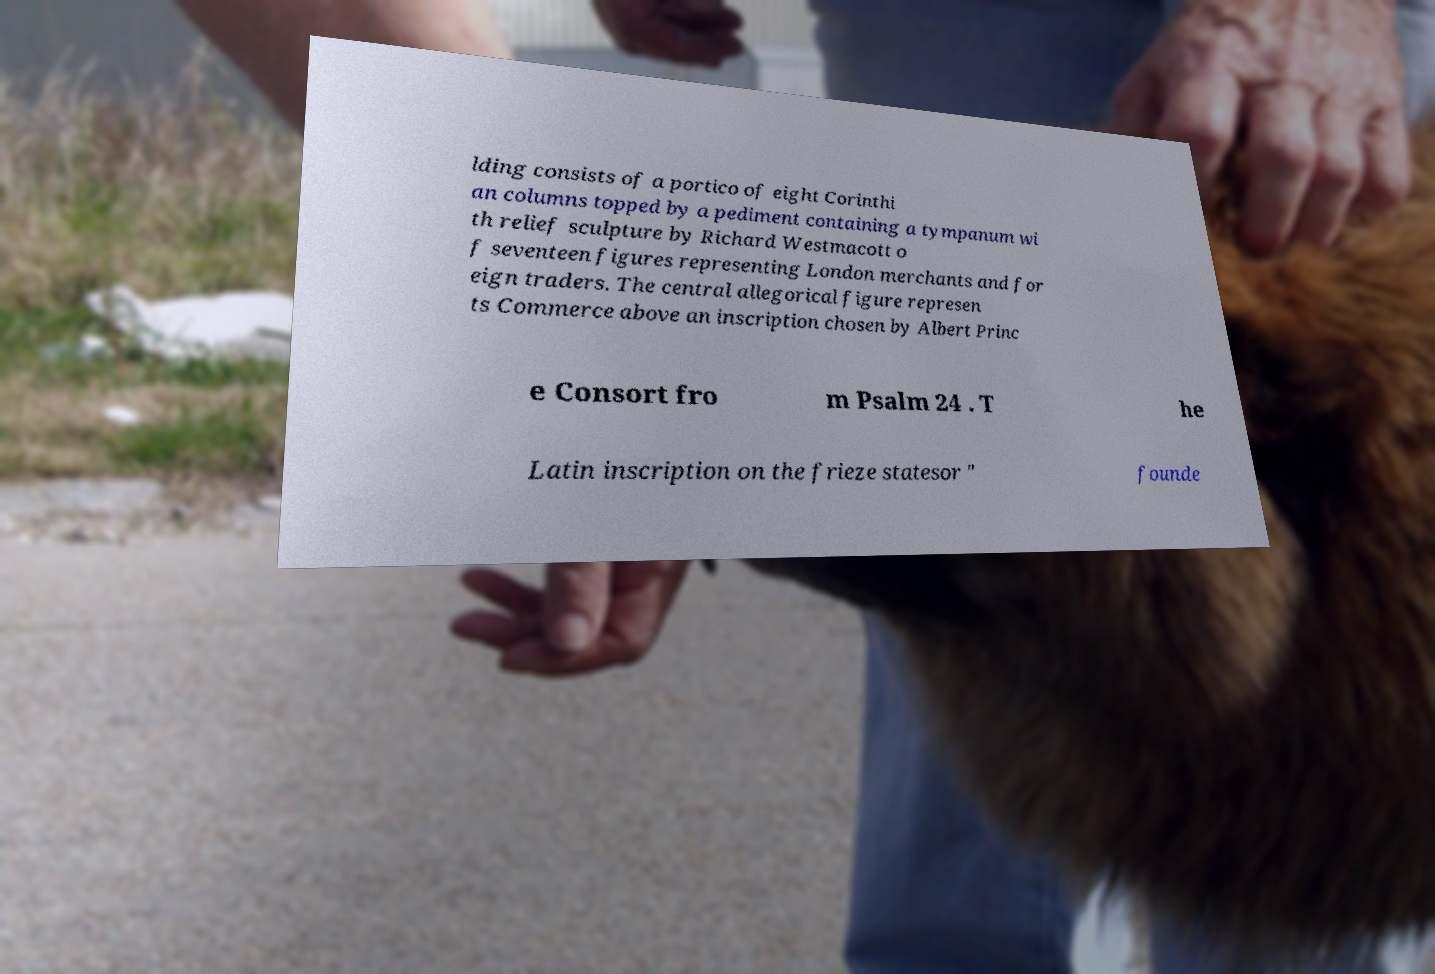Could you assist in decoding the text presented in this image and type it out clearly? lding consists of a portico of eight Corinthi an columns topped by a pediment containing a tympanum wi th relief sculpture by Richard Westmacott o f seventeen figures representing London merchants and for eign traders. The central allegorical figure represen ts Commerce above an inscription chosen by Albert Princ e Consort fro m Psalm 24 . T he Latin inscription on the frieze statesor " founde 